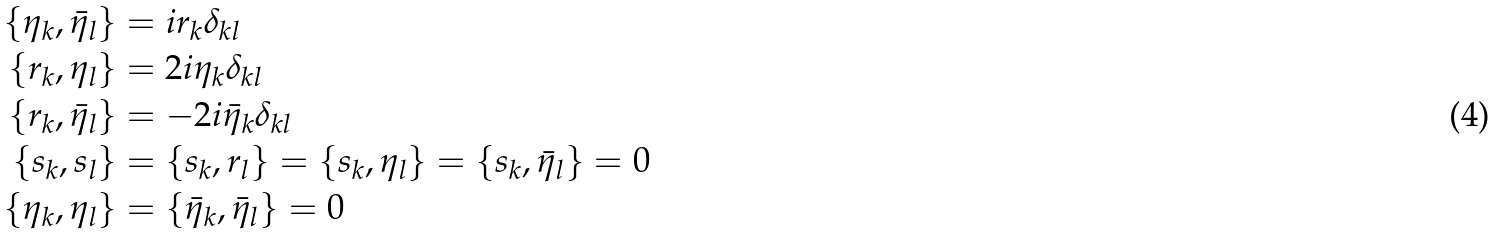Convert formula to latex. <formula><loc_0><loc_0><loc_500><loc_500>\{ \eta _ { k } , \bar { \eta } _ { l } \} & = i r _ { k } \delta _ { k l } \\ \{ r _ { k } , \eta _ { l } \} & = 2 i \eta _ { k } \delta _ { k l } \\ \{ r _ { k } , \bar { \eta } _ { l } \} & = - 2 i \bar { \eta } _ { k } \delta _ { k l } \\ \{ s _ { k } , s _ { l } \} & = \{ s _ { k } , r _ { l } \} = \{ s _ { k } , \eta _ { l } \} = \{ s _ { k } , \bar { \eta } _ { l } \} = 0 \\ \{ \eta _ { k } , \eta _ { l } \} & = \{ \bar { \eta } _ { k } , \bar { \eta } _ { l } \} = 0</formula> 